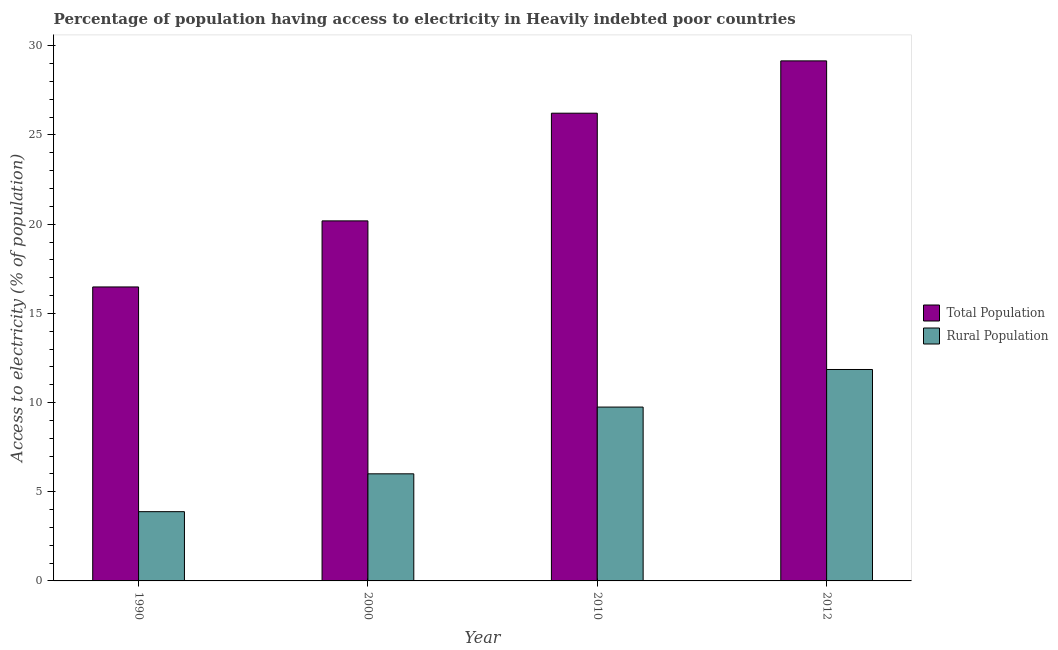How many groups of bars are there?
Offer a very short reply. 4. Are the number of bars per tick equal to the number of legend labels?
Provide a succinct answer. Yes. Are the number of bars on each tick of the X-axis equal?
Offer a very short reply. Yes. What is the label of the 1st group of bars from the left?
Offer a very short reply. 1990. In how many cases, is the number of bars for a given year not equal to the number of legend labels?
Your response must be concise. 0. What is the percentage of rural population having access to electricity in 2012?
Your answer should be very brief. 11.85. Across all years, what is the maximum percentage of rural population having access to electricity?
Offer a terse response. 11.85. Across all years, what is the minimum percentage of population having access to electricity?
Your answer should be very brief. 16.48. In which year was the percentage of population having access to electricity minimum?
Offer a terse response. 1990. What is the total percentage of population having access to electricity in the graph?
Your answer should be compact. 92.04. What is the difference between the percentage of rural population having access to electricity in 2000 and that in 2012?
Give a very brief answer. -5.85. What is the difference between the percentage of rural population having access to electricity in 2000 and the percentage of population having access to electricity in 2010?
Your answer should be very brief. -3.74. What is the average percentage of rural population having access to electricity per year?
Keep it short and to the point. 7.87. In how many years, is the percentage of rural population having access to electricity greater than 1 %?
Provide a succinct answer. 4. What is the ratio of the percentage of rural population having access to electricity in 1990 to that in 2012?
Give a very brief answer. 0.33. Is the difference between the percentage of rural population having access to electricity in 2000 and 2010 greater than the difference between the percentage of population having access to electricity in 2000 and 2010?
Your answer should be compact. No. What is the difference between the highest and the second highest percentage of population having access to electricity?
Offer a very short reply. 2.93. What is the difference between the highest and the lowest percentage of rural population having access to electricity?
Ensure brevity in your answer.  7.97. Is the sum of the percentage of rural population having access to electricity in 2010 and 2012 greater than the maximum percentage of population having access to electricity across all years?
Provide a succinct answer. Yes. What does the 1st bar from the left in 1990 represents?
Give a very brief answer. Total Population. What does the 2nd bar from the right in 2012 represents?
Your response must be concise. Total Population. How many bars are there?
Provide a short and direct response. 8. How many years are there in the graph?
Your response must be concise. 4. What is the difference between two consecutive major ticks on the Y-axis?
Your answer should be compact. 5. Are the values on the major ticks of Y-axis written in scientific E-notation?
Offer a very short reply. No. Where does the legend appear in the graph?
Provide a succinct answer. Center right. What is the title of the graph?
Provide a succinct answer. Percentage of population having access to electricity in Heavily indebted poor countries. What is the label or title of the X-axis?
Your answer should be very brief. Year. What is the label or title of the Y-axis?
Offer a very short reply. Access to electricity (% of population). What is the Access to electricity (% of population) of Total Population in 1990?
Make the answer very short. 16.48. What is the Access to electricity (% of population) in Rural Population in 1990?
Your response must be concise. 3.88. What is the Access to electricity (% of population) in Total Population in 2000?
Keep it short and to the point. 20.18. What is the Access to electricity (% of population) in Rural Population in 2000?
Offer a very short reply. 6. What is the Access to electricity (% of population) in Total Population in 2010?
Offer a very short reply. 26.22. What is the Access to electricity (% of population) in Rural Population in 2010?
Offer a terse response. 9.75. What is the Access to electricity (% of population) of Total Population in 2012?
Provide a succinct answer. 29.15. What is the Access to electricity (% of population) of Rural Population in 2012?
Your answer should be compact. 11.85. Across all years, what is the maximum Access to electricity (% of population) of Total Population?
Make the answer very short. 29.15. Across all years, what is the maximum Access to electricity (% of population) in Rural Population?
Your answer should be compact. 11.85. Across all years, what is the minimum Access to electricity (% of population) in Total Population?
Make the answer very short. 16.48. Across all years, what is the minimum Access to electricity (% of population) in Rural Population?
Offer a very short reply. 3.88. What is the total Access to electricity (% of population) in Total Population in the graph?
Make the answer very short. 92.04. What is the total Access to electricity (% of population) in Rural Population in the graph?
Make the answer very short. 31.49. What is the difference between the Access to electricity (% of population) of Total Population in 1990 and that in 2000?
Provide a short and direct response. -3.7. What is the difference between the Access to electricity (% of population) of Rural Population in 1990 and that in 2000?
Your answer should be compact. -2.12. What is the difference between the Access to electricity (% of population) of Total Population in 1990 and that in 2010?
Your answer should be very brief. -9.74. What is the difference between the Access to electricity (% of population) of Rural Population in 1990 and that in 2010?
Your response must be concise. -5.86. What is the difference between the Access to electricity (% of population) of Total Population in 1990 and that in 2012?
Keep it short and to the point. -12.67. What is the difference between the Access to electricity (% of population) of Rural Population in 1990 and that in 2012?
Give a very brief answer. -7.97. What is the difference between the Access to electricity (% of population) of Total Population in 2000 and that in 2010?
Offer a terse response. -6.04. What is the difference between the Access to electricity (% of population) of Rural Population in 2000 and that in 2010?
Your answer should be compact. -3.74. What is the difference between the Access to electricity (% of population) in Total Population in 2000 and that in 2012?
Provide a succinct answer. -8.97. What is the difference between the Access to electricity (% of population) in Rural Population in 2000 and that in 2012?
Your answer should be compact. -5.85. What is the difference between the Access to electricity (% of population) in Total Population in 2010 and that in 2012?
Ensure brevity in your answer.  -2.93. What is the difference between the Access to electricity (% of population) of Rural Population in 2010 and that in 2012?
Offer a very short reply. -2.11. What is the difference between the Access to electricity (% of population) of Total Population in 1990 and the Access to electricity (% of population) of Rural Population in 2000?
Your response must be concise. 10.48. What is the difference between the Access to electricity (% of population) in Total Population in 1990 and the Access to electricity (% of population) in Rural Population in 2010?
Provide a short and direct response. 6.73. What is the difference between the Access to electricity (% of population) of Total Population in 1990 and the Access to electricity (% of population) of Rural Population in 2012?
Give a very brief answer. 4.63. What is the difference between the Access to electricity (% of population) of Total Population in 2000 and the Access to electricity (% of population) of Rural Population in 2010?
Your response must be concise. 10.44. What is the difference between the Access to electricity (% of population) of Total Population in 2000 and the Access to electricity (% of population) of Rural Population in 2012?
Keep it short and to the point. 8.33. What is the difference between the Access to electricity (% of population) in Total Population in 2010 and the Access to electricity (% of population) in Rural Population in 2012?
Your response must be concise. 14.37. What is the average Access to electricity (% of population) of Total Population per year?
Your answer should be compact. 23.01. What is the average Access to electricity (% of population) in Rural Population per year?
Your response must be concise. 7.87. In the year 1990, what is the difference between the Access to electricity (% of population) in Total Population and Access to electricity (% of population) in Rural Population?
Offer a very short reply. 12.6. In the year 2000, what is the difference between the Access to electricity (% of population) of Total Population and Access to electricity (% of population) of Rural Population?
Your answer should be compact. 14.18. In the year 2010, what is the difference between the Access to electricity (% of population) of Total Population and Access to electricity (% of population) of Rural Population?
Ensure brevity in your answer.  16.47. In the year 2012, what is the difference between the Access to electricity (% of population) in Total Population and Access to electricity (% of population) in Rural Population?
Offer a terse response. 17.3. What is the ratio of the Access to electricity (% of population) in Total Population in 1990 to that in 2000?
Provide a short and direct response. 0.82. What is the ratio of the Access to electricity (% of population) of Rural Population in 1990 to that in 2000?
Keep it short and to the point. 0.65. What is the ratio of the Access to electricity (% of population) of Total Population in 1990 to that in 2010?
Provide a succinct answer. 0.63. What is the ratio of the Access to electricity (% of population) in Rural Population in 1990 to that in 2010?
Offer a terse response. 0.4. What is the ratio of the Access to electricity (% of population) of Total Population in 1990 to that in 2012?
Your response must be concise. 0.57. What is the ratio of the Access to electricity (% of population) of Rural Population in 1990 to that in 2012?
Keep it short and to the point. 0.33. What is the ratio of the Access to electricity (% of population) of Total Population in 2000 to that in 2010?
Provide a short and direct response. 0.77. What is the ratio of the Access to electricity (% of population) of Rural Population in 2000 to that in 2010?
Offer a very short reply. 0.62. What is the ratio of the Access to electricity (% of population) of Total Population in 2000 to that in 2012?
Provide a short and direct response. 0.69. What is the ratio of the Access to electricity (% of population) of Rural Population in 2000 to that in 2012?
Keep it short and to the point. 0.51. What is the ratio of the Access to electricity (% of population) in Total Population in 2010 to that in 2012?
Keep it short and to the point. 0.9. What is the ratio of the Access to electricity (% of population) in Rural Population in 2010 to that in 2012?
Your answer should be compact. 0.82. What is the difference between the highest and the second highest Access to electricity (% of population) of Total Population?
Make the answer very short. 2.93. What is the difference between the highest and the second highest Access to electricity (% of population) of Rural Population?
Provide a short and direct response. 2.11. What is the difference between the highest and the lowest Access to electricity (% of population) of Total Population?
Ensure brevity in your answer.  12.67. What is the difference between the highest and the lowest Access to electricity (% of population) of Rural Population?
Your response must be concise. 7.97. 